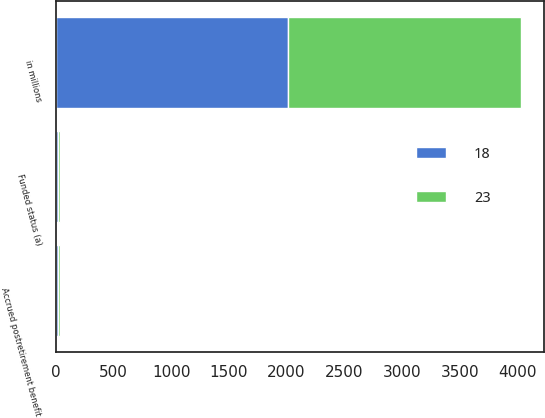<chart> <loc_0><loc_0><loc_500><loc_500><stacked_bar_chart><ecel><fcel>in millions<fcel>Funded status (a)<fcel>Accrued postretirement benefit<nl><fcel>23<fcel>2015<fcel>18<fcel>18<nl><fcel>18<fcel>2014<fcel>23<fcel>23<nl></chart> 